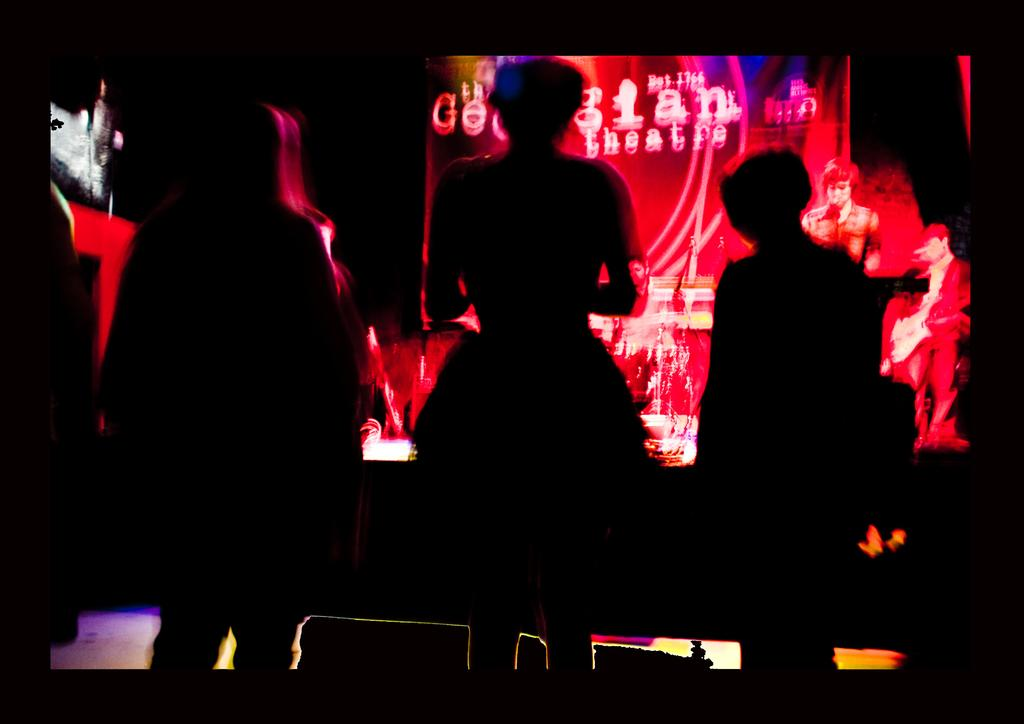What is happening in the image? There are people standing in the image. What can be seen in the background of the image? There is a colorful poster with text in the background of the image. What type of paste is being used by the people in the image? There is no paste present in the image, and the people are not using any paste. 